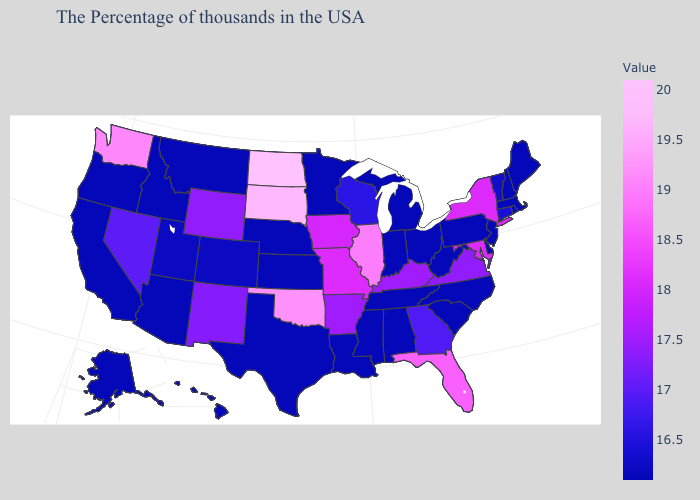Which states have the highest value in the USA?
Concise answer only. North Dakota. Among the states that border Georgia , which have the highest value?
Short answer required. Florida. Which states hav the highest value in the MidWest?
Quick response, please. North Dakota. Which states have the lowest value in the USA?
Give a very brief answer. Maine, Massachusetts, Rhode Island, New Hampshire, New Jersey, Delaware, Pennsylvania, North Carolina, South Carolina, West Virginia, Ohio, Michigan, Indiana, Alabama, Tennessee, Mississippi, Louisiana, Minnesota, Kansas, Nebraska, Texas, Montana, Arizona, Idaho, California, Oregon, Alaska, Hawaii. Among the states that border Colorado , does Oklahoma have the lowest value?
Write a very short answer. No. Among the states that border West Virginia , does Virginia have the lowest value?
Give a very brief answer. No. Is the legend a continuous bar?
Write a very short answer. Yes. 